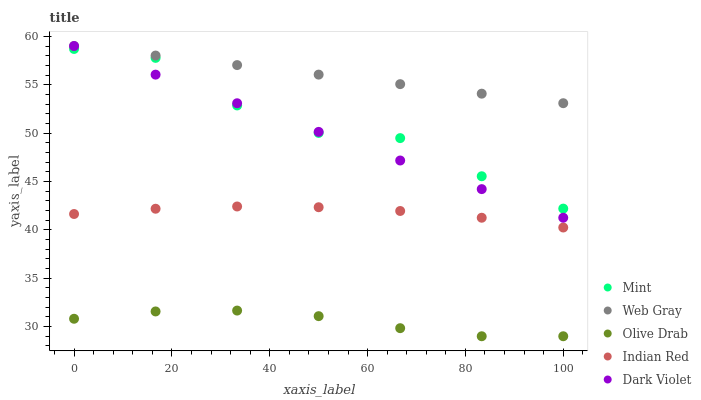Does Olive Drab have the minimum area under the curve?
Answer yes or no. Yes. Does Web Gray have the maximum area under the curve?
Answer yes or no. Yes. Does Mint have the minimum area under the curve?
Answer yes or no. No. Does Mint have the maximum area under the curve?
Answer yes or no. No. Is Dark Violet the smoothest?
Answer yes or no. Yes. Is Mint the roughest?
Answer yes or no. Yes. Is Web Gray the smoothest?
Answer yes or no. No. Is Web Gray the roughest?
Answer yes or no. No. Does Olive Drab have the lowest value?
Answer yes or no. Yes. Does Mint have the lowest value?
Answer yes or no. No. Does Web Gray have the highest value?
Answer yes or no. Yes. Does Mint have the highest value?
Answer yes or no. No. Is Indian Red less than Web Gray?
Answer yes or no. Yes. Is Mint greater than Indian Red?
Answer yes or no. Yes. Does Mint intersect Dark Violet?
Answer yes or no. Yes. Is Mint less than Dark Violet?
Answer yes or no. No. Is Mint greater than Dark Violet?
Answer yes or no. No. Does Indian Red intersect Web Gray?
Answer yes or no. No. 